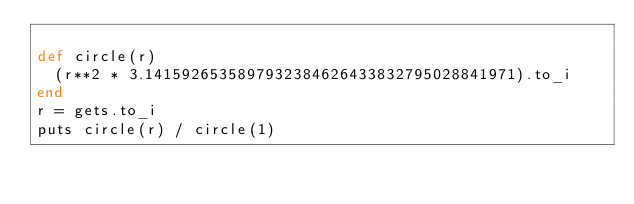<code> <loc_0><loc_0><loc_500><loc_500><_Ruby_>
def circle(r)
  (r**2 * 3.1415926535897932384626433832795028841971).to_i
end
r = gets.to_i
puts circle(r) / circle(1)
</code> 